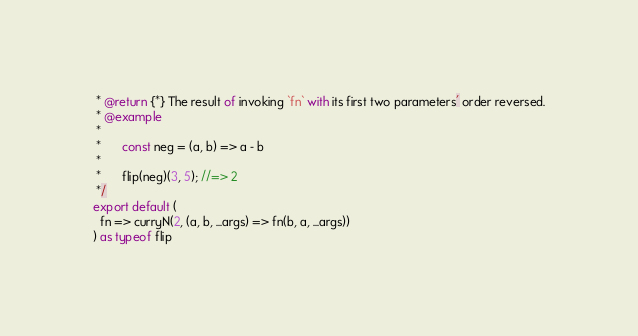<code> <loc_0><loc_0><loc_500><loc_500><_TypeScript_> * @return {*} The result of invoking `fn` with its first two parameters' order reversed.
 * @example
 *
 *      const neg = (a, b) => a - b
 *
 *      flip(neg)(3, 5); //=> 2
 */
export default (
  fn => curryN(2, (a, b, ...args) => fn(b, a, ...args))
) as typeof flip
</code> 